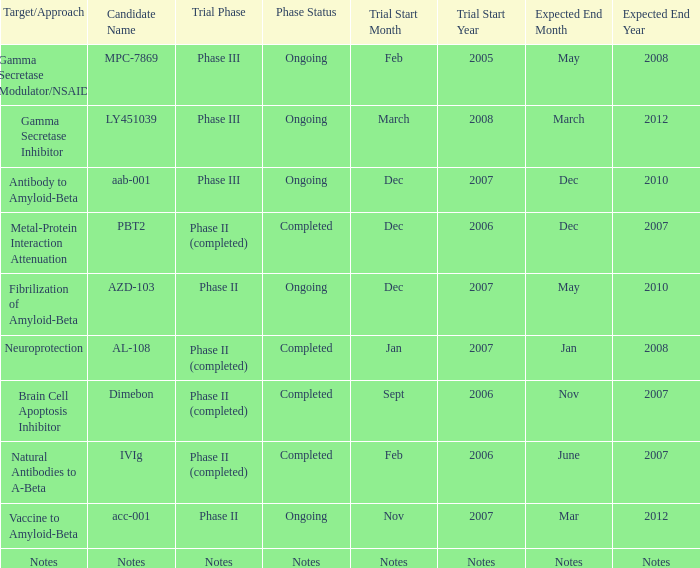Could you help me parse every detail presented in this table? {'header': ['Target/Approach', 'Candidate Name', 'Trial Phase', 'Phase Status', 'Trial Start Month', 'Trial Start Year', 'Expected End Month', 'Expected End Year'], 'rows': [['Gamma Secretase Modulator/NSAID', 'MPC-7869', 'Phase III', 'Ongoing', 'Feb', '2005', 'May', '2008'], ['Gamma Secretase Inhibitor', 'LY451039', 'Phase III', 'Ongoing', 'March', '2008', 'March', '2012'], ['Antibody to Amyloid-Beta', 'aab-001', 'Phase III', 'Ongoing', 'Dec', '2007', 'Dec', '2010'], ['Metal-Protein Interaction Attenuation', 'PBT2', 'Phase II (completed)', 'Completed', 'Dec', '2006', 'Dec', '2007'], ['Fibrilization of Amyloid-Beta', 'AZD-103', 'Phase II', 'Ongoing', 'Dec', '2007', 'May', '2010'], ['Neuroprotection', 'AL-108', 'Phase II (completed)', 'Completed', 'Jan', '2007', 'Jan', '2008'], ['Brain Cell Apoptosis Inhibitor', 'Dimebon', 'Phase II (completed)', 'Completed', 'Sept', '2006', 'Nov', '2007'], ['Natural Antibodies to A-Beta', 'IVIg', 'Phase II (completed)', 'Completed', 'Feb', '2006', 'June', '2007'], ['Vaccine to Amyloid-Beta', 'acc-001', 'Phase II', 'Ongoing', 'Nov', '2007', 'Mar', '2012'], ['Notes', 'Notes', 'Notes', 'Notes', 'Notes', 'Notes', 'Notes', 'Notes']]} When the trial start date is nov 2007, what is the anticipated end date? Mar 2012. 